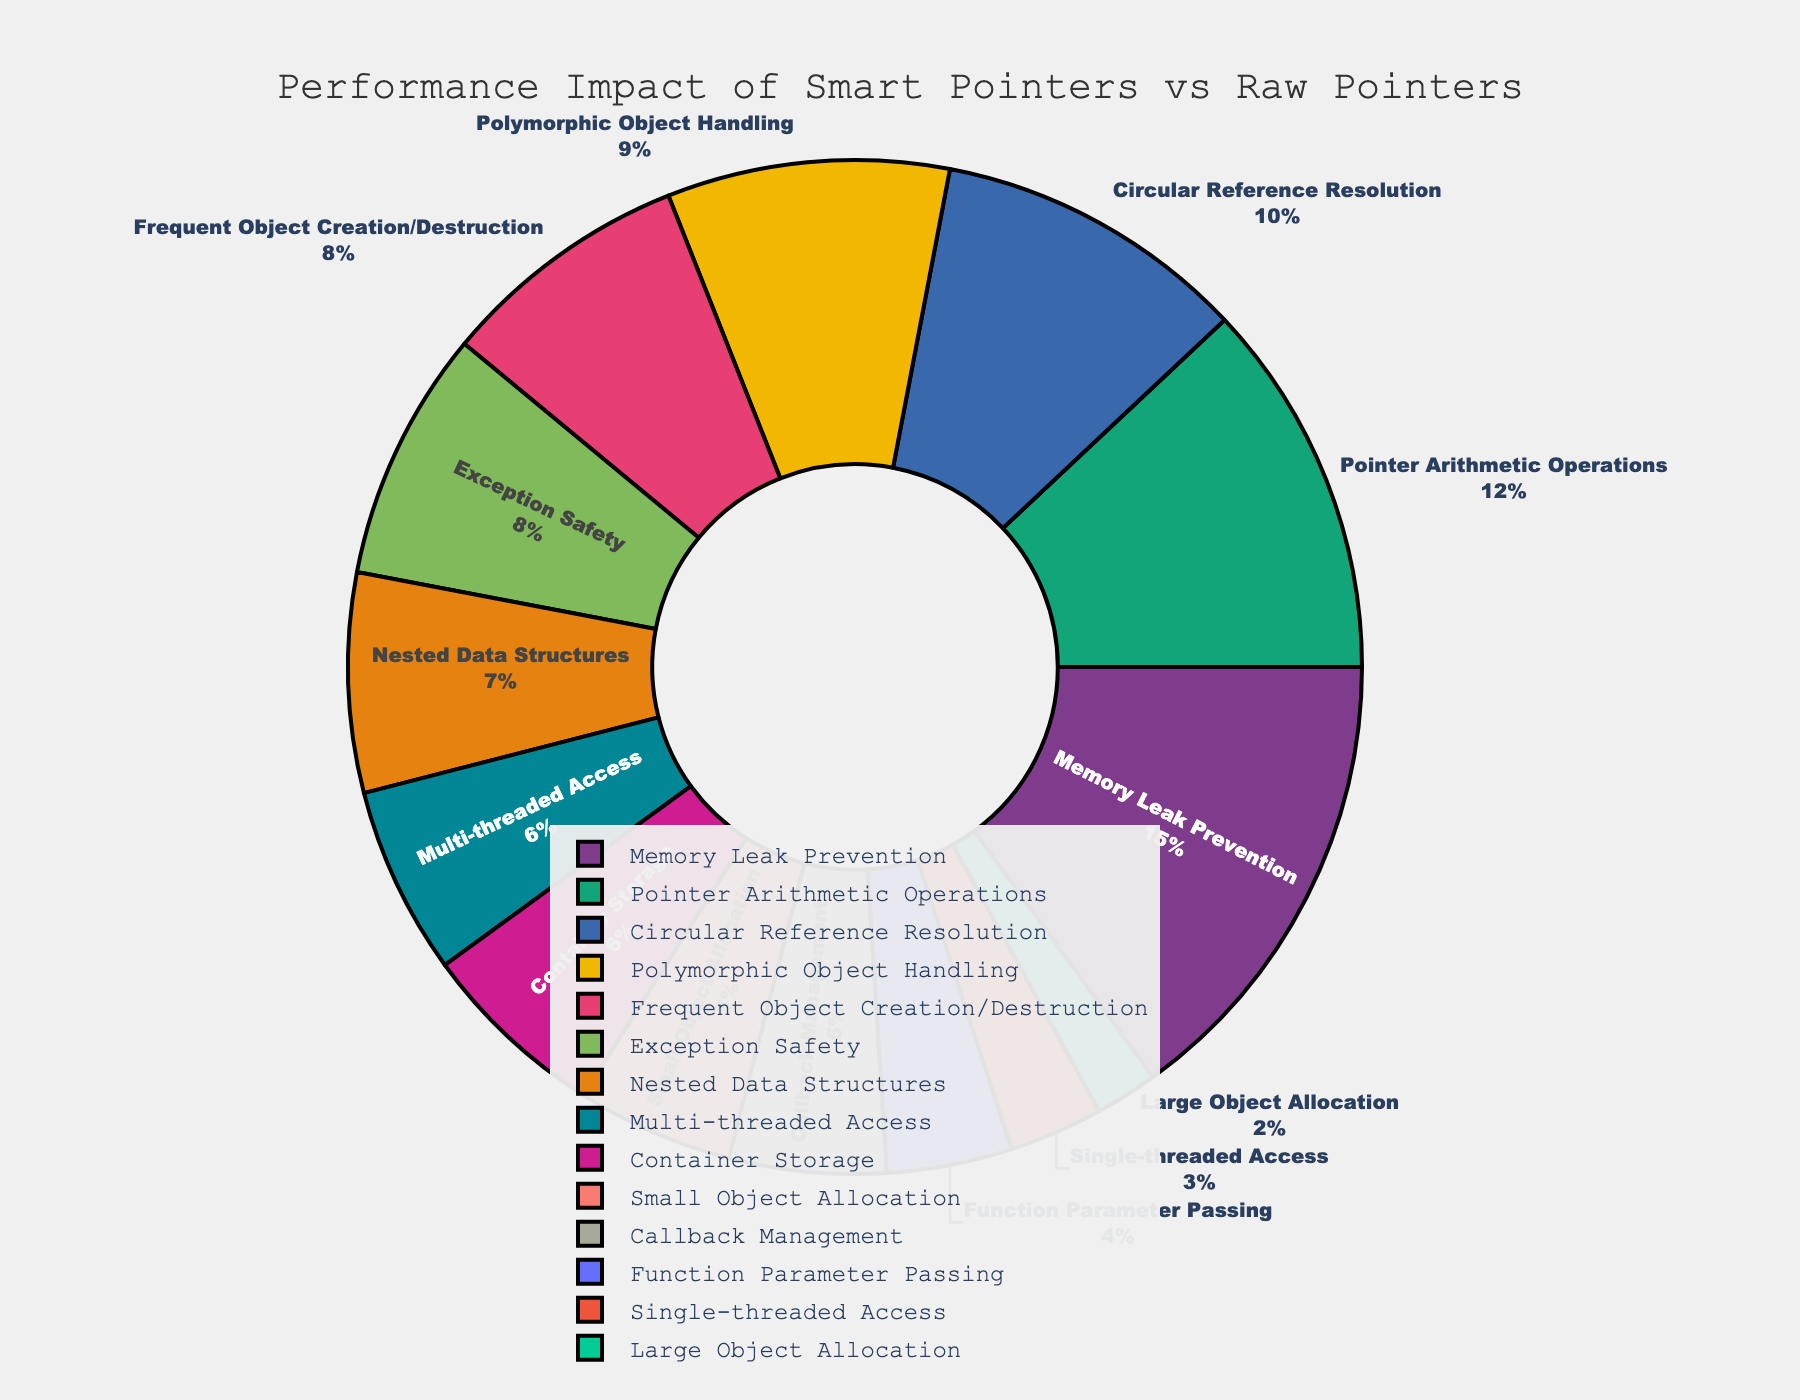Which scenario has the highest performance impact? First, locate the scenario with the largest percentage in the pie chart, which should be prominently featured. The data indicates "Memory Leak Prevention" has the highest percentage impact.
Answer: Memory Leak Prevention Which scenario has the lowest performance impact? Identify the scenario with the smallest percentage slice in the pie chart. The data indicates "Large Object Allocation" has the lowest percentage impact.
Answer: Large Object Allocation What is the total performance impact percentage for scenarios involving object allocation? Sum up the performance impacts for "Small Object Allocation" (5%) and "Large Object Allocation" (2%). 5% + 2% = 7%.
Answer: 7% How does the performance impact of "Exception Safety" compare to "Polymorphic Object Handling"? Compare their values directly from the pie chart. "Exception Safety" is 8% and "Polymorphic Object Handling" is 9%. The performance impact of exception safety is less than polymorphic object handling.
Answer: Exception Safety is less than Polymorphic Object Handling What is the average performance impact percentage across all scenarios? Sum the percentages of all scenarios and divide by the number of scenarios (15). (5+2+8+3+6+12+4+7+9+15+10+8+6+5)/15 = 6.93%.
Answer: 6.93% Which scenario is directly opposite to "Frequent Object Creation/Destruction" on the pie chart? Visually identify the scenario that is on the opposite side of the pie chart from "Frequent Object Creation/Destruction". From the data, it's likely "Nested Data Structures".
Answer: Nested Data Structures What's the combined performance impact percentage of "Single-threaded Access" and "Multi-threaded Access"? Sum the percentages for "Single-threaded Access" (3%) and "Multi-threaded Access" (6%). 3% + 6% = 9%.
Answer: 9% How much higher is the performance impact of "Pointer Arithmetic Operations" compared to "Function Parameter Passing"? Subtract the percentage of "Function Parameter Passing" (4%) from "Pointer Arithmetic Operations" (12%). 12% - 4% = 8%.
Answer: 8% What is the performance impact of scenarios related to thread management? Sum the percentages of "Single-threaded Access" (3%) and "Multi-threaded Access" (6%). 3% + 6% = 9%.
Answer: 9% Among the given scenarios, which ones have a performance impact greater than 7%? Identify the scenarios and their corresponding percentages and check if the percentage is greater than 7%. The scenarios are "Frequent Object Creation/Destruction" (8%), "Polymorphic Object Handling" (9%), "Memory Leak Prevention" (15%), "Circular Reference Resolution" (10%), and "Exception Safety" (8%).
Answer: Frequent Object Creation/Destruction, Polymorphic Object Handling, Memory Leak Prevention, Circular Reference Resolution, Exception Safety 